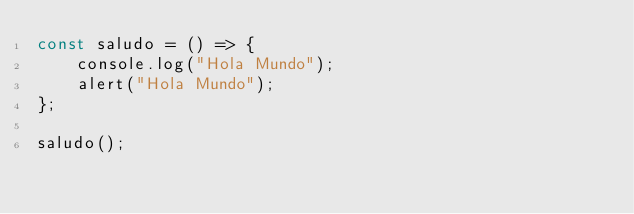Convert code to text. <code><loc_0><loc_0><loc_500><loc_500><_JavaScript_>const saludo = () => {
    console.log("Hola Mundo");
    alert("Hola Mundo");
};

saludo();</code> 